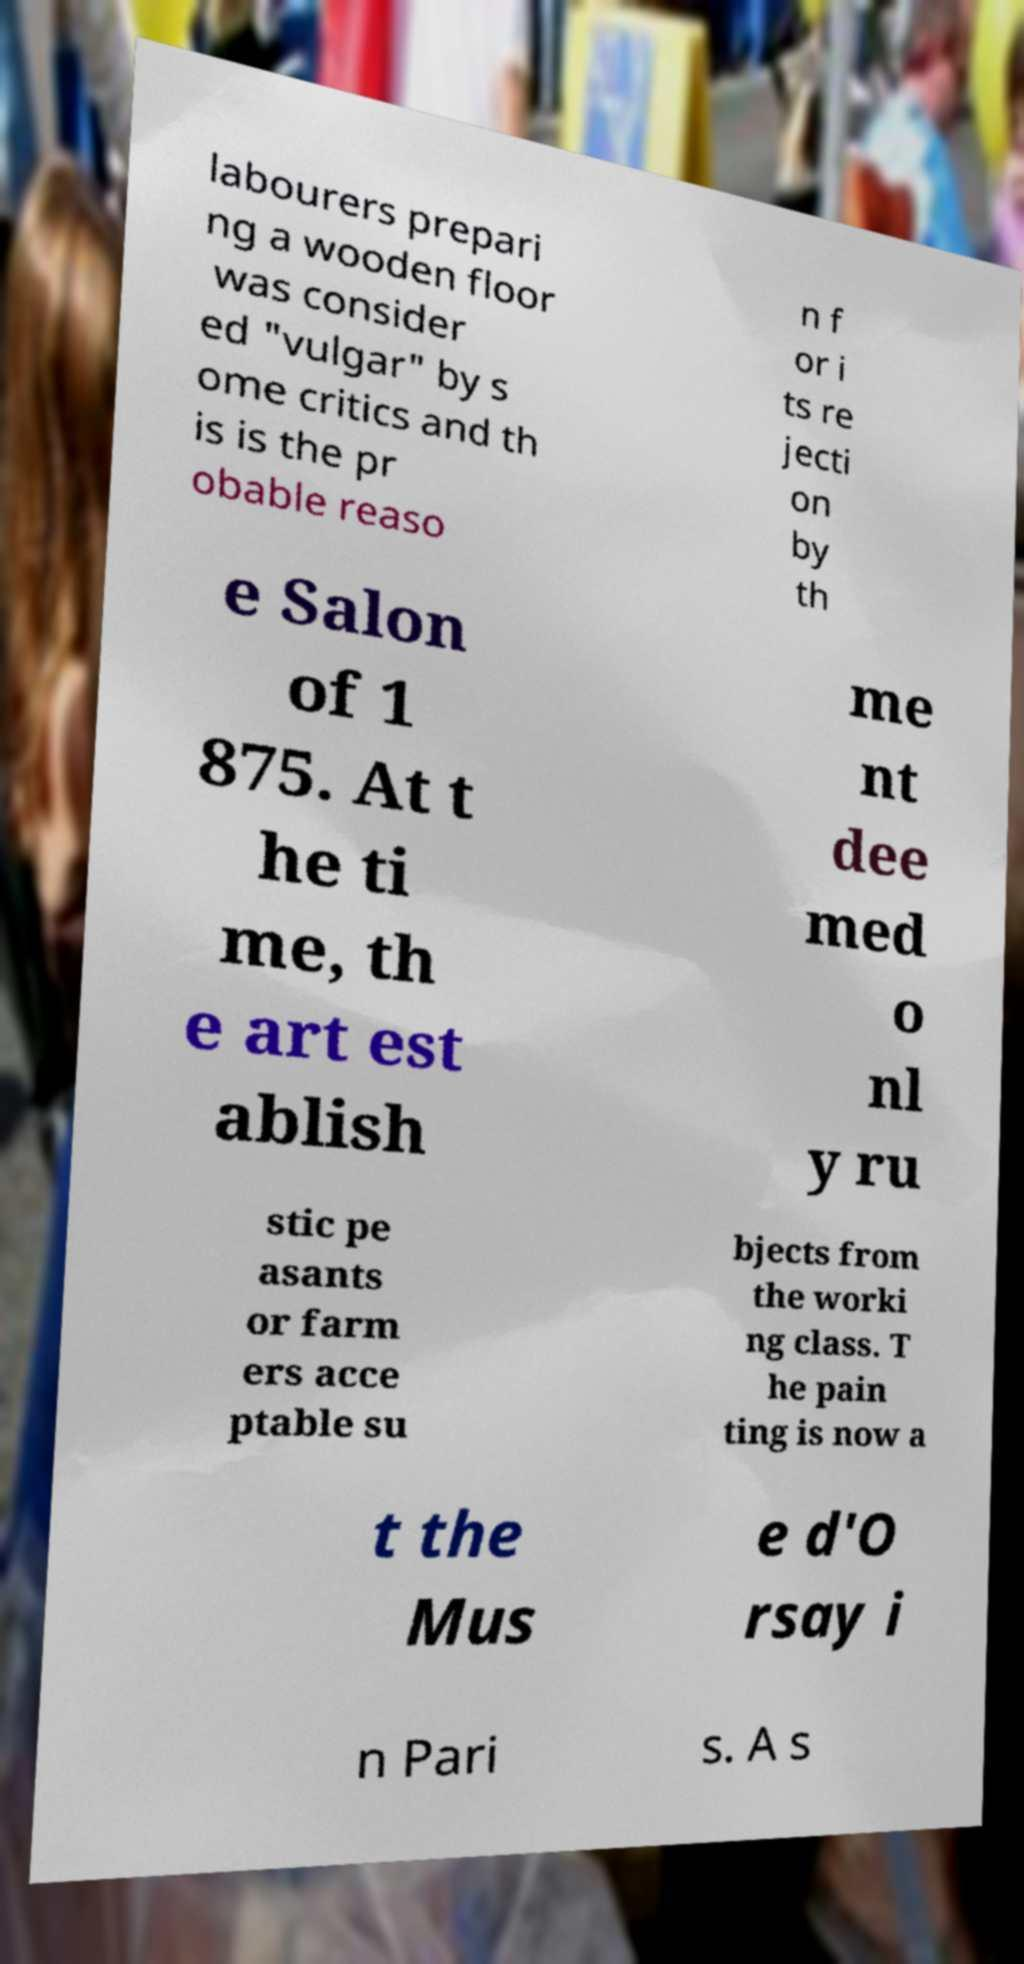Please read and relay the text visible in this image. What does it say? labourers prepari ng a wooden floor was consider ed "vulgar" by s ome critics and th is is the pr obable reaso n f or i ts re jecti on by th e Salon of 1 875. At t he ti me, th e art est ablish me nt dee med o nl y ru stic pe asants or farm ers acce ptable su bjects from the worki ng class. T he pain ting is now a t the Mus e d'O rsay i n Pari s. A s 